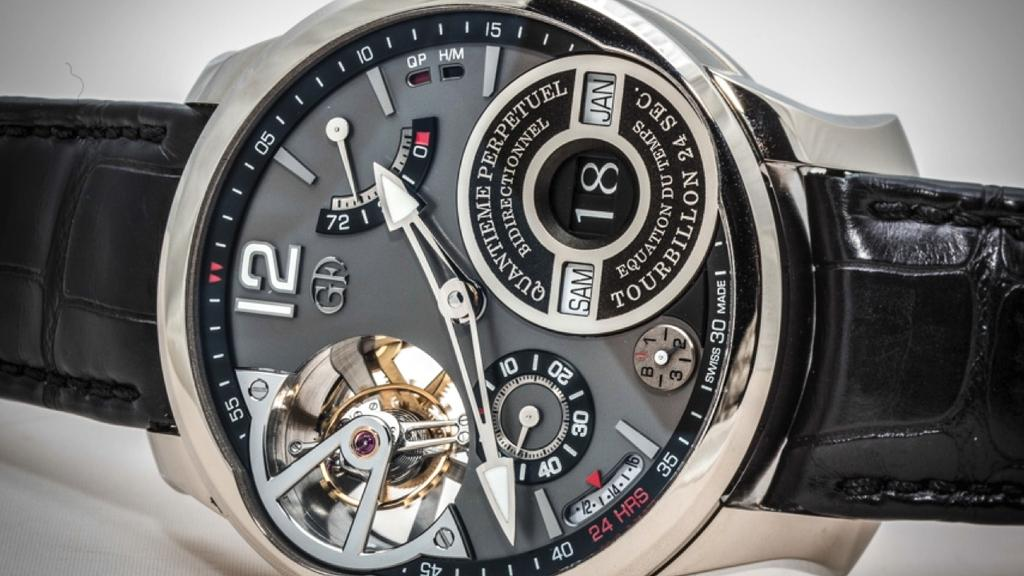<image>
Offer a succinct explanation of the picture presented. A GF watch shows the time to be 1:41. 